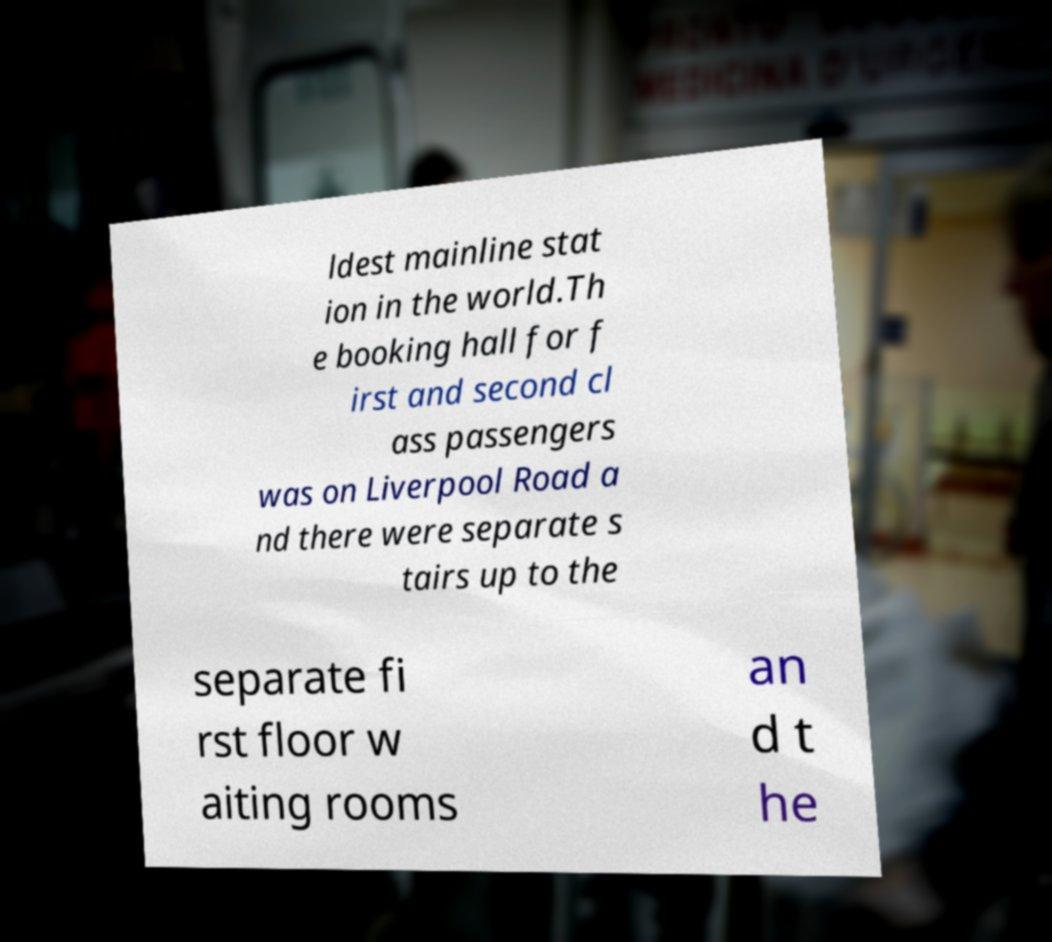For documentation purposes, I need the text within this image transcribed. Could you provide that? ldest mainline stat ion in the world.Th e booking hall for f irst and second cl ass passengers was on Liverpool Road a nd there were separate s tairs up to the separate fi rst floor w aiting rooms an d t he 